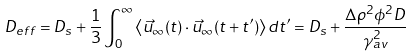Convert formula to latex. <formula><loc_0><loc_0><loc_500><loc_500>D _ { e f f } = D _ { s } + \frac { 1 } { 3 } \int _ { 0 } ^ { \infty } \left < \vec { u } _ { \infty } ( t ) \cdot \vec { u } _ { \infty } ( t + t ^ { \prime } ) \right > d t ^ { \prime } = D _ { s } + \frac { \Delta \rho ^ { 2 } \phi ^ { 2 } D } { \gamma _ { a v } ^ { 2 } }</formula> 